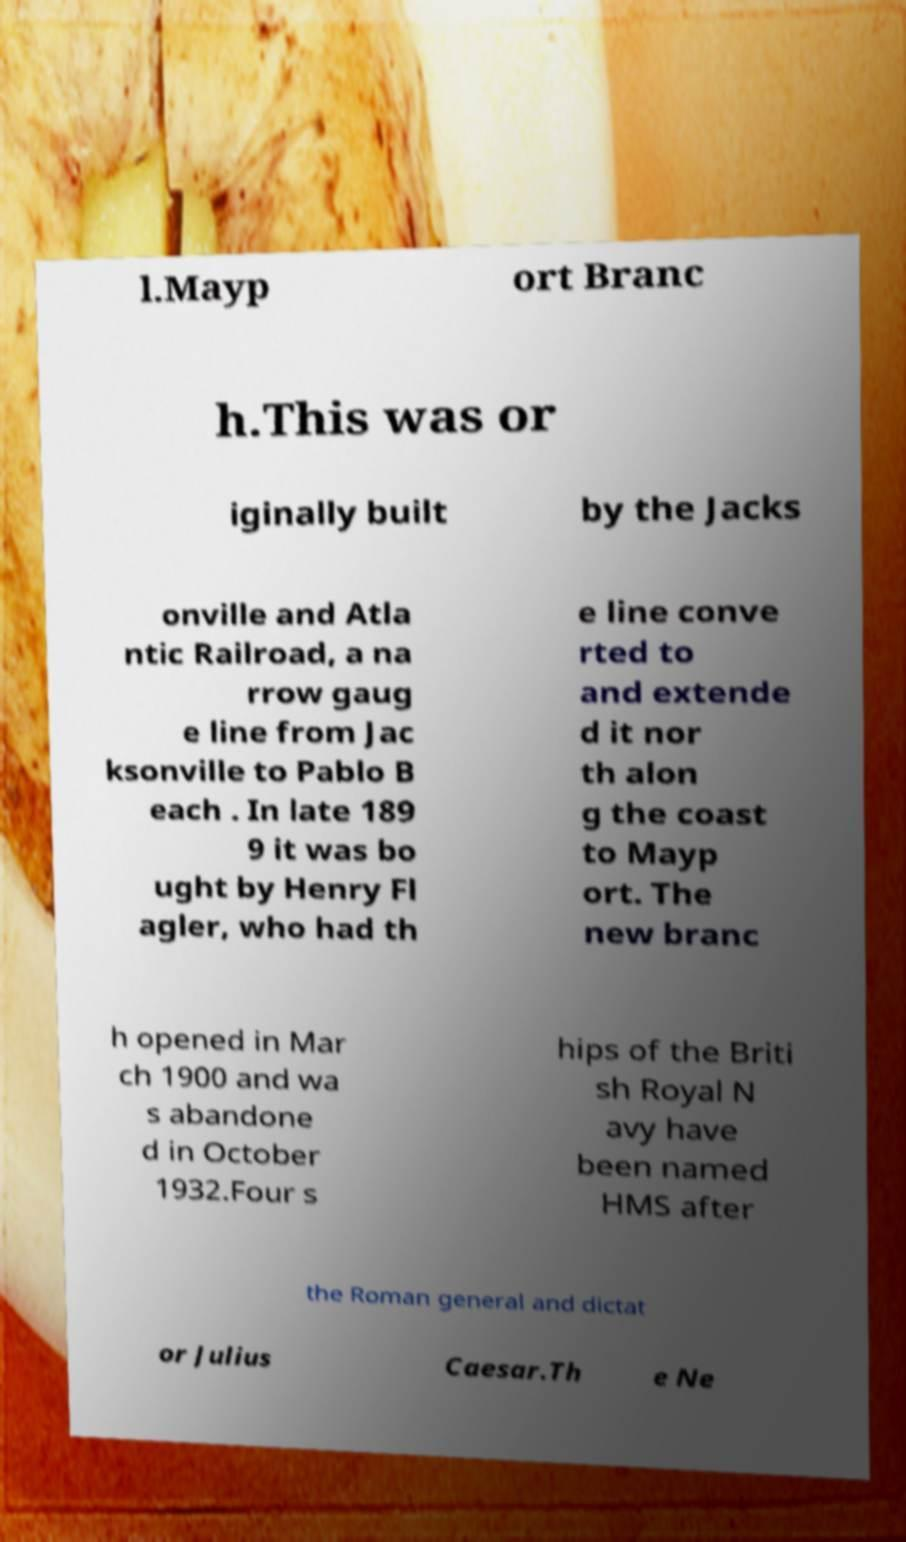There's text embedded in this image that I need extracted. Can you transcribe it verbatim? l.Mayp ort Branc h.This was or iginally built by the Jacks onville and Atla ntic Railroad, a na rrow gaug e line from Jac ksonville to Pablo B each . In late 189 9 it was bo ught by Henry Fl agler, who had th e line conve rted to and extende d it nor th alon g the coast to Mayp ort. The new branc h opened in Mar ch 1900 and wa s abandone d in October 1932.Four s hips of the Briti sh Royal N avy have been named HMS after the Roman general and dictat or Julius Caesar.Th e Ne 